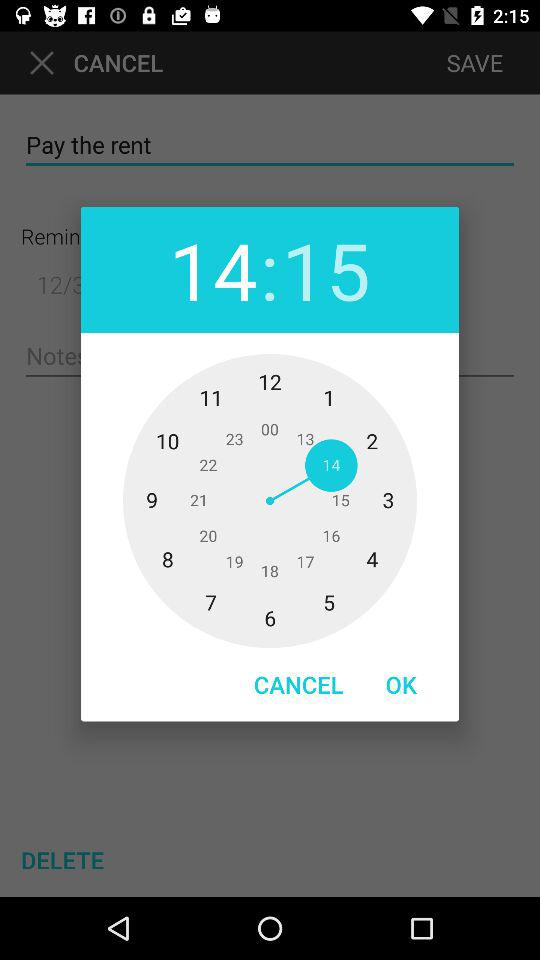What is the time selected to pay the rent? The selected time is 14:15. 